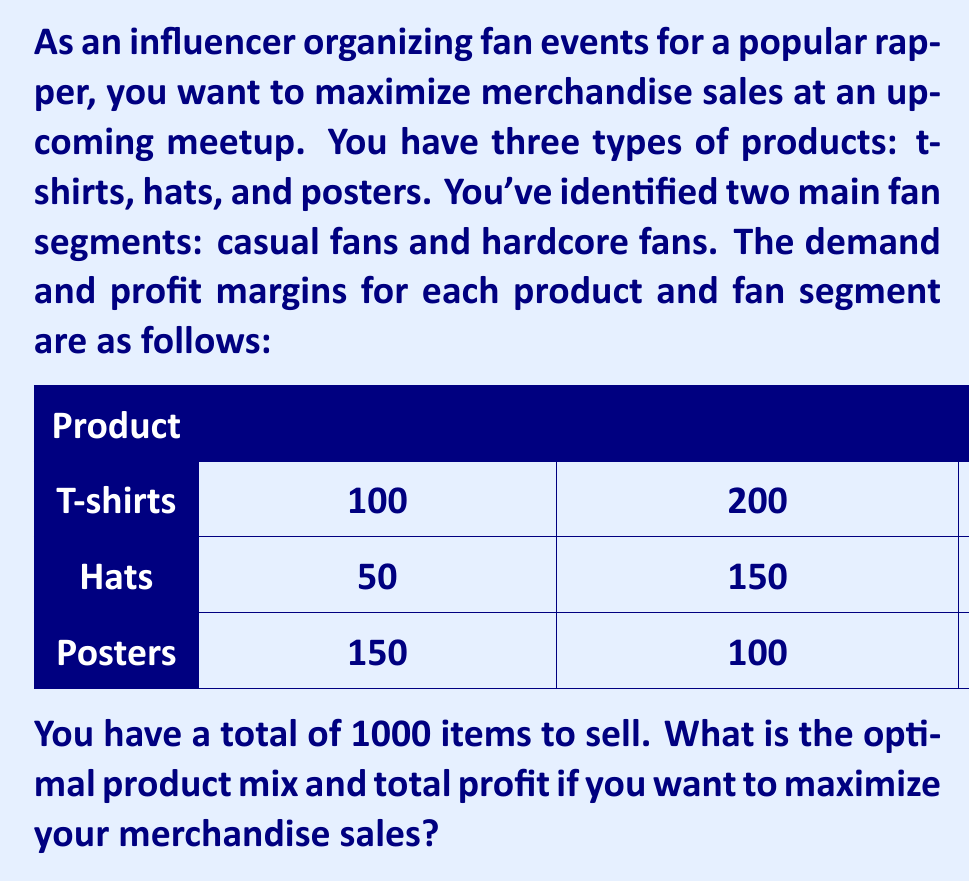Can you answer this question? To solve this optimization problem, we'll use the following steps:

1) Define variables:
   Let $x_1$, $x_2$, and $x_3$ be the number of t-shirts, hats, and posters respectively.

2) Set up the objective function:
   We want to maximize profit, so our objective function is:
   $$\text{Profit} = 35x_1 + 22x_2 + 13x_3$$
   (Sum of profits from both fan segments for each product)

3) Define constraints:
   a) Total items constraint: $x_1 + x_2 + x_3 \leq 1000$
   b) Demand constraints:
      T-shirts: $x_1 \leq 300$
      Hats: $x_2 \leq 200$
      Posters: $x_3 \leq 250$
   c) Non-negativity: $x_1, x_2, x_3 \geq 0$

4) Solve using the simplex method or linear programming software:
   The optimal solution is:
   $x_1 = 300$ (T-shirts)
   $x_2 = 200$ (Hats)
   $x_3 = 250$ (Posters)

5) Calculate the maximum profit:
   $$\text{Max Profit} = 35(300) + 22(200) + 13(250) = 10,500 + 4,400 + 3,250 = \$18,150$$

Therefore, the optimal product mix is 300 t-shirts, 200 hats, and 250 posters, which will yield a maximum profit of $18,150.
Answer: 300 t-shirts, 200 hats, 250 posters; $18,150 profit 